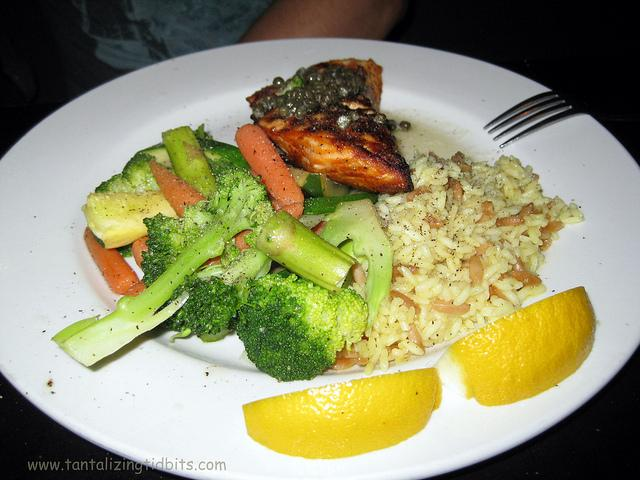What type of dish is this?

Choices:
A) dessert
B) side dish
C) entree
D) appetizer entree 